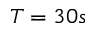<formula> <loc_0><loc_0><loc_500><loc_500>T = 3 0 s</formula> 